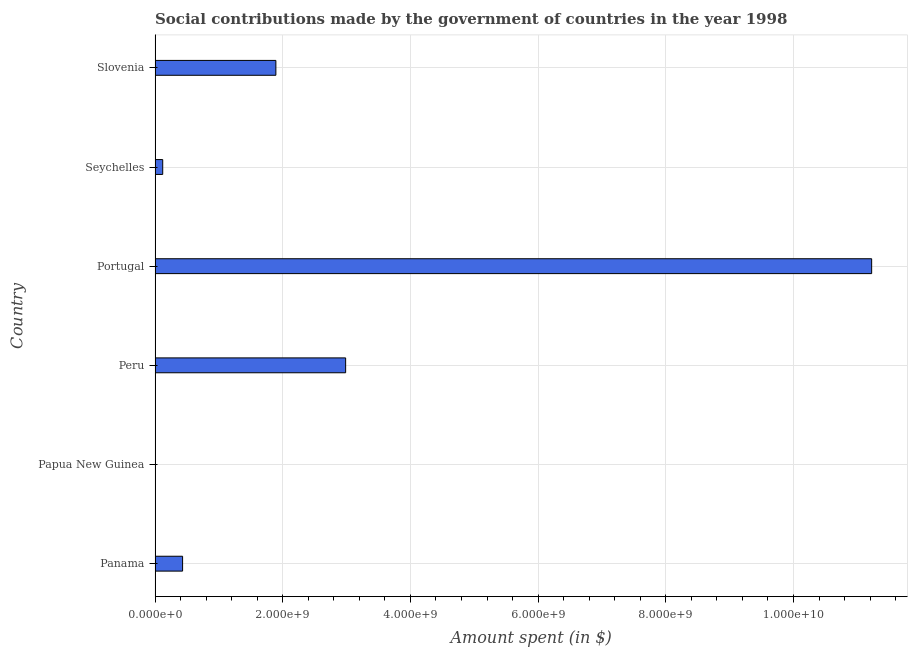Does the graph contain any zero values?
Your response must be concise. No. Does the graph contain grids?
Offer a very short reply. Yes. What is the title of the graph?
Your response must be concise. Social contributions made by the government of countries in the year 1998. What is the label or title of the X-axis?
Offer a terse response. Amount spent (in $). What is the amount spent in making social contributions in Panama?
Offer a terse response. 4.31e+08. Across all countries, what is the maximum amount spent in making social contributions?
Make the answer very short. 1.12e+1. Across all countries, what is the minimum amount spent in making social contributions?
Make the answer very short. 4.65e+06. In which country was the amount spent in making social contributions maximum?
Make the answer very short. Portugal. In which country was the amount spent in making social contributions minimum?
Your answer should be compact. Papua New Guinea. What is the sum of the amount spent in making social contributions?
Give a very brief answer. 1.67e+1. What is the difference between the amount spent in making social contributions in Panama and Seychelles?
Make the answer very short. 3.12e+08. What is the average amount spent in making social contributions per country?
Provide a short and direct response. 2.78e+09. What is the median amount spent in making social contributions?
Your answer should be very brief. 1.16e+09. What is the ratio of the amount spent in making social contributions in Papua New Guinea to that in Portugal?
Offer a very short reply. 0. Is the difference between the amount spent in making social contributions in Papua New Guinea and Slovenia greater than the difference between any two countries?
Provide a succinct answer. No. What is the difference between the highest and the second highest amount spent in making social contributions?
Provide a short and direct response. 8.24e+09. Is the sum of the amount spent in making social contributions in Panama and Slovenia greater than the maximum amount spent in making social contributions across all countries?
Your response must be concise. No. What is the difference between the highest and the lowest amount spent in making social contributions?
Offer a very short reply. 1.12e+1. In how many countries, is the amount spent in making social contributions greater than the average amount spent in making social contributions taken over all countries?
Your answer should be very brief. 2. How many countries are there in the graph?
Your response must be concise. 6. What is the Amount spent (in $) of Panama?
Your response must be concise. 4.31e+08. What is the Amount spent (in $) of Papua New Guinea?
Offer a terse response. 4.65e+06. What is the Amount spent (in $) of Peru?
Your answer should be very brief. 2.99e+09. What is the Amount spent (in $) in Portugal?
Your response must be concise. 1.12e+1. What is the Amount spent (in $) of Seychelles?
Your answer should be compact. 1.20e+08. What is the Amount spent (in $) in Slovenia?
Offer a terse response. 1.89e+09. What is the difference between the Amount spent (in $) in Panama and Papua New Guinea?
Provide a succinct answer. 4.27e+08. What is the difference between the Amount spent (in $) in Panama and Peru?
Offer a terse response. -2.55e+09. What is the difference between the Amount spent (in $) in Panama and Portugal?
Offer a very short reply. -1.08e+1. What is the difference between the Amount spent (in $) in Panama and Seychelles?
Make the answer very short. 3.12e+08. What is the difference between the Amount spent (in $) in Panama and Slovenia?
Keep it short and to the point. -1.46e+09. What is the difference between the Amount spent (in $) in Papua New Guinea and Peru?
Give a very brief answer. -2.98e+09. What is the difference between the Amount spent (in $) in Papua New Guinea and Portugal?
Keep it short and to the point. -1.12e+1. What is the difference between the Amount spent (in $) in Papua New Guinea and Seychelles?
Provide a short and direct response. -1.15e+08. What is the difference between the Amount spent (in $) in Papua New Guinea and Slovenia?
Offer a terse response. -1.89e+09. What is the difference between the Amount spent (in $) in Peru and Portugal?
Keep it short and to the point. -8.24e+09. What is the difference between the Amount spent (in $) in Peru and Seychelles?
Provide a short and direct response. 2.87e+09. What is the difference between the Amount spent (in $) in Peru and Slovenia?
Your response must be concise. 1.09e+09. What is the difference between the Amount spent (in $) in Portugal and Seychelles?
Give a very brief answer. 1.11e+1. What is the difference between the Amount spent (in $) in Portugal and Slovenia?
Your answer should be compact. 9.33e+09. What is the difference between the Amount spent (in $) in Seychelles and Slovenia?
Provide a succinct answer. -1.77e+09. What is the ratio of the Amount spent (in $) in Panama to that in Papua New Guinea?
Your answer should be compact. 92.77. What is the ratio of the Amount spent (in $) in Panama to that in Peru?
Keep it short and to the point. 0.14. What is the ratio of the Amount spent (in $) in Panama to that in Portugal?
Provide a succinct answer. 0.04. What is the ratio of the Amount spent (in $) in Panama to that in Seychelles?
Provide a short and direct response. 3.6. What is the ratio of the Amount spent (in $) in Panama to that in Slovenia?
Ensure brevity in your answer.  0.23. What is the ratio of the Amount spent (in $) in Papua New Guinea to that in Peru?
Your answer should be very brief. 0. What is the ratio of the Amount spent (in $) in Papua New Guinea to that in Seychelles?
Provide a succinct answer. 0.04. What is the ratio of the Amount spent (in $) in Papua New Guinea to that in Slovenia?
Offer a very short reply. 0. What is the ratio of the Amount spent (in $) in Peru to that in Portugal?
Your answer should be compact. 0.27. What is the ratio of the Amount spent (in $) in Peru to that in Seychelles?
Offer a terse response. 24.9. What is the ratio of the Amount spent (in $) in Peru to that in Slovenia?
Your response must be concise. 1.58. What is the ratio of the Amount spent (in $) in Portugal to that in Seychelles?
Make the answer very short. 93.62. What is the ratio of the Amount spent (in $) in Portugal to that in Slovenia?
Offer a very short reply. 5.93. What is the ratio of the Amount spent (in $) in Seychelles to that in Slovenia?
Offer a terse response. 0.06. 